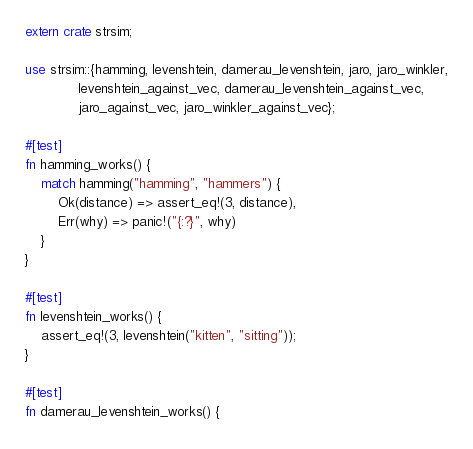Convert code to text. <code><loc_0><loc_0><loc_500><loc_500><_Rust_>extern crate strsim;

use strsim::{hamming, levenshtein, damerau_levenshtein, jaro, jaro_winkler,
             levenshtein_against_vec, damerau_levenshtein_against_vec,
             jaro_against_vec, jaro_winkler_against_vec};

#[test]
fn hamming_works() {
    match hamming("hamming", "hammers") {
        Ok(distance) => assert_eq!(3, distance),
        Err(why) => panic!("{:?}", why)
    }
}

#[test]
fn levenshtein_works() {
    assert_eq!(3, levenshtein("kitten", "sitting"));
}

#[test]
fn damerau_levenshtein_works() {</code> 